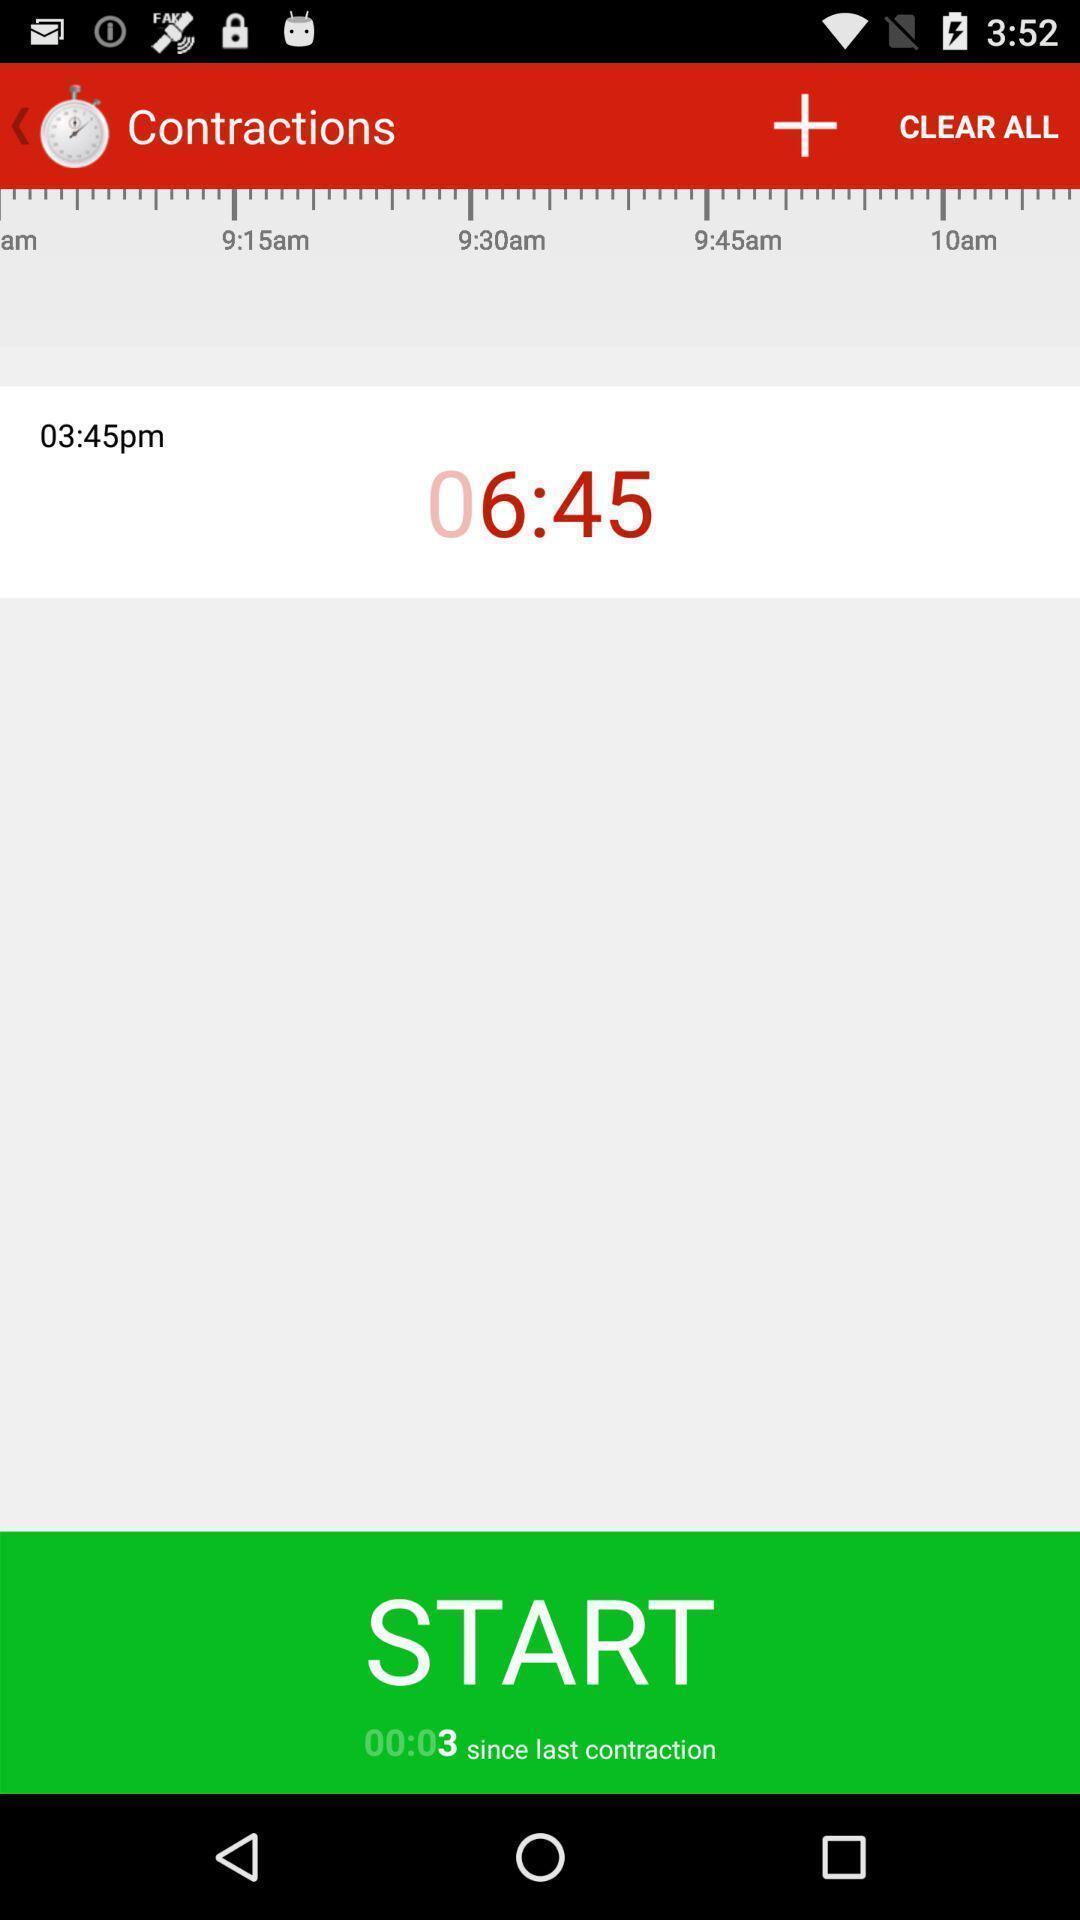Summarize the main components in this picture. Start page of a contractions timer. 